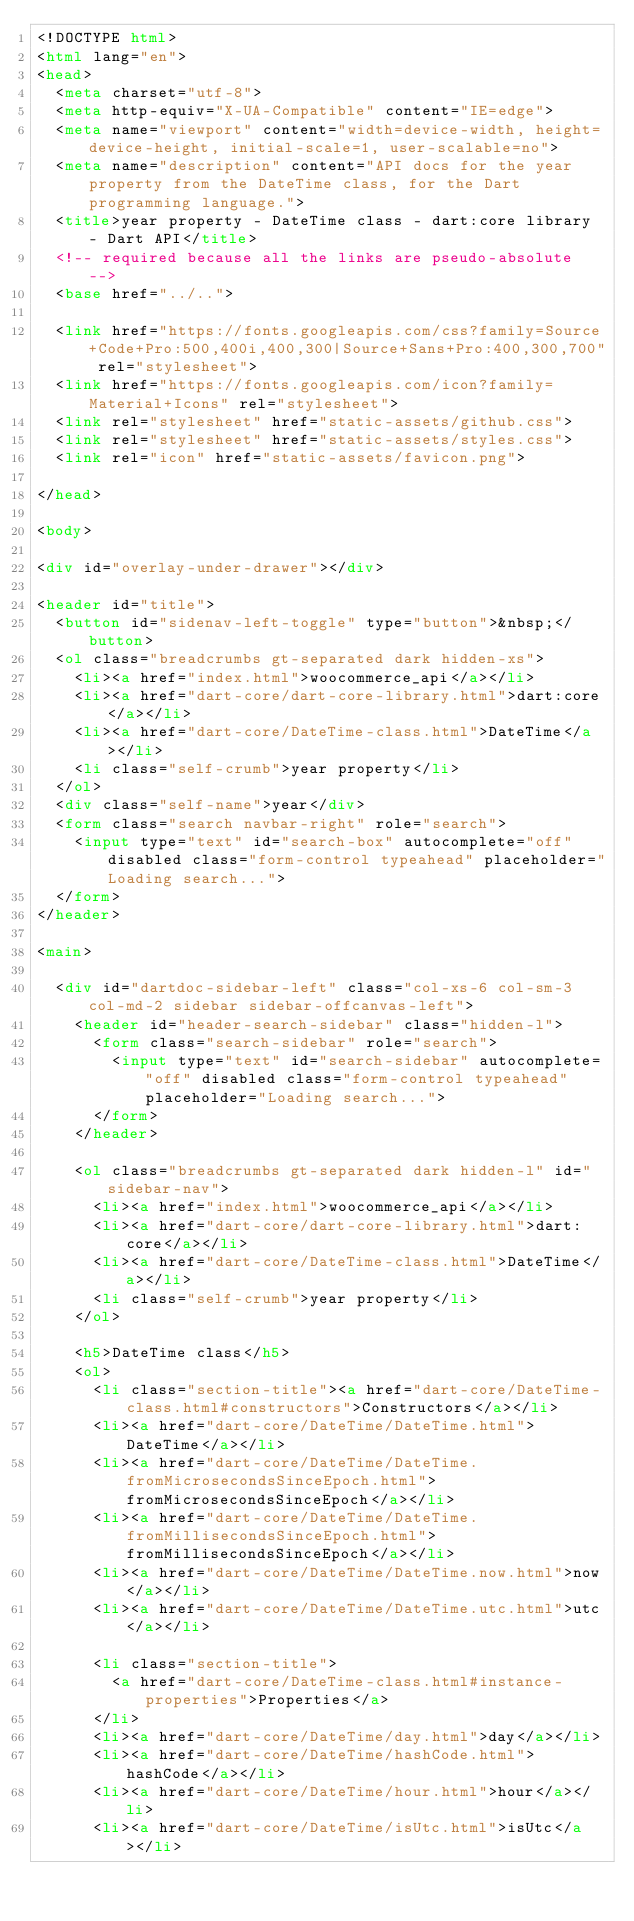<code> <loc_0><loc_0><loc_500><loc_500><_HTML_><!DOCTYPE html>
<html lang="en">
<head>
  <meta charset="utf-8">
  <meta http-equiv="X-UA-Compatible" content="IE=edge">
  <meta name="viewport" content="width=device-width, height=device-height, initial-scale=1, user-scalable=no">
  <meta name="description" content="API docs for the year property from the DateTime class, for the Dart programming language.">
  <title>year property - DateTime class - dart:core library - Dart API</title>
  <!-- required because all the links are pseudo-absolute -->
  <base href="../..">

  <link href="https://fonts.googleapis.com/css?family=Source+Code+Pro:500,400i,400,300|Source+Sans+Pro:400,300,700" rel="stylesheet">
  <link href="https://fonts.googleapis.com/icon?family=Material+Icons" rel="stylesheet">
  <link rel="stylesheet" href="static-assets/github.css">
  <link rel="stylesheet" href="static-assets/styles.css">
  <link rel="icon" href="static-assets/favicon.png">
  
</head>

<body>

<div id="overlay-under-drawer"></div>

<header id="title">
  <button id="sidenav-left-toggle" type="button">&nbsp;</button>
  <ol class="breadcrumbs gt-separated dark hidden-xs">
    <li><a href="index.html">woocommerce_api</a></li>
    <li><a href="dart-core/dart-core-library.html">dart:core</a></li>
    <li><a href="dart-core/DateTime-class.html">DateTime</a></li>
    <li class="self-crumb">year property</li>
  </ol>
  <div class="self-name">year</div>
  <form class="search navbar-right" role="search">
    <input type="text" id="search-box" autocomplete="off" disabled class="form-control typeahead" placeholder="Loading search...">
  </form>
</header>

<main>

  <div id="dartdoc-sidebar-left" class="col-xs-6 col-sm-3 col-md-2 sidebar sidebar-offcanvas-left">
    <header id="header-search-sidebar" class="hidden-l">
      <form class="search-sidebar" role="search">
        <input type="text" id="search-sidebar" autocomplete="off" disabled class="form-control typeahead" placeholder="Loading search...">
      </form>
    </header>
    
    <ol class="breadcrumbs gt-separated dark hidden-l" id="sidebar-nav">
      <li><a href="index.html">woocommerce_api</a></li>
      <li><a href="dart-core/dart-core-library.html">dart:core</a></li>
      <li><a href="dart-core/DateTime-class.html">DateTime</a></li>
      <li class="self-crumb">year property</li>
    </ol>
    
    <h5>DateTime class</h5>
    <ol>
      <li class="section-title"><a href="dart-core/DateTime-class.html#constructors">Constructors</a></li>
      <li><a href="dart-core/DateTime/DateTime.html">DateTime</a></li>
      <li><a href="dart-core/DateTime/DateTime.fromMicrosecondsSinceEpoch.html">fromMicrosecondsSinceEpoch</a></li>
      <li><a href="dart-core/DateTime/DateTime.fromMillisecondsSinceEpoch.html">fromMillisecondsSinceEpoch</a></li>
      <li><a href="dart-core/DateTime/DateTime.now.html">now</a></li>
      <li><a href="dart-core/DateTime/DateTime.utc.html">utc</a></li>
    
      <li class="section-title">
        <a href="dart-core/DateTime-class.html#instance-properties">Properties</a>
      </li>
      <li><a href="dart-core/DateTime/day.html">day</a></li>
      <li><a href="dart-core/DateTime/hashCode.html">hashCode</a></li>
      <li><a href="dart-core/DateTime/hour.html">hour</a></li>
      <li><a href="dart-core/DateTime/isUtc.html">isUtc</a></li></code> 